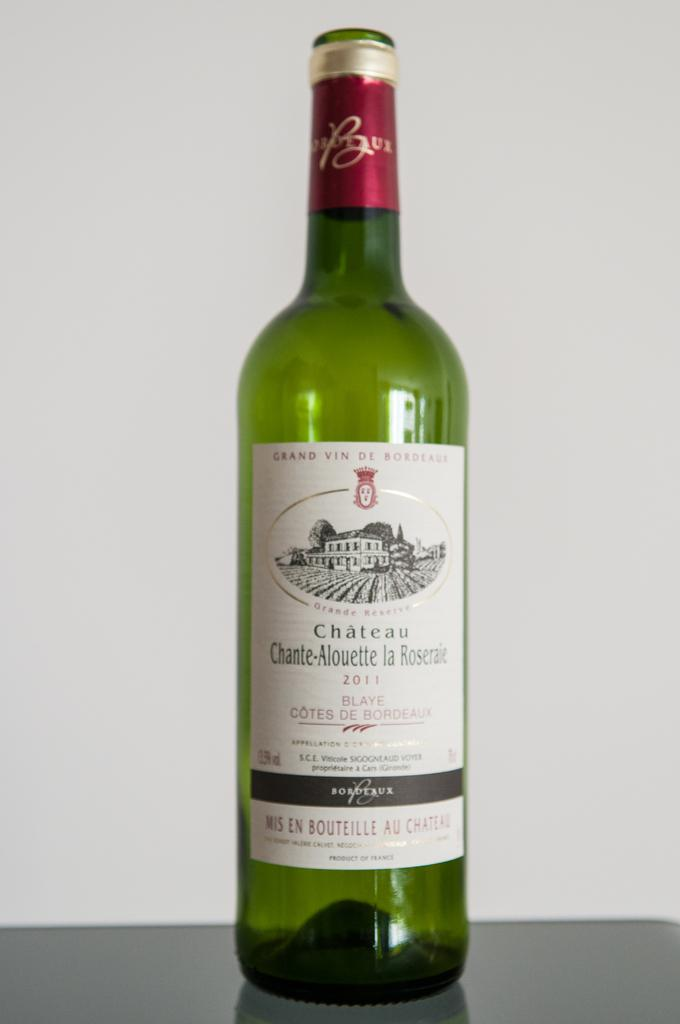<image>
Provide a brief description of the given image. A bottle of Chateau is sitting on the table. 